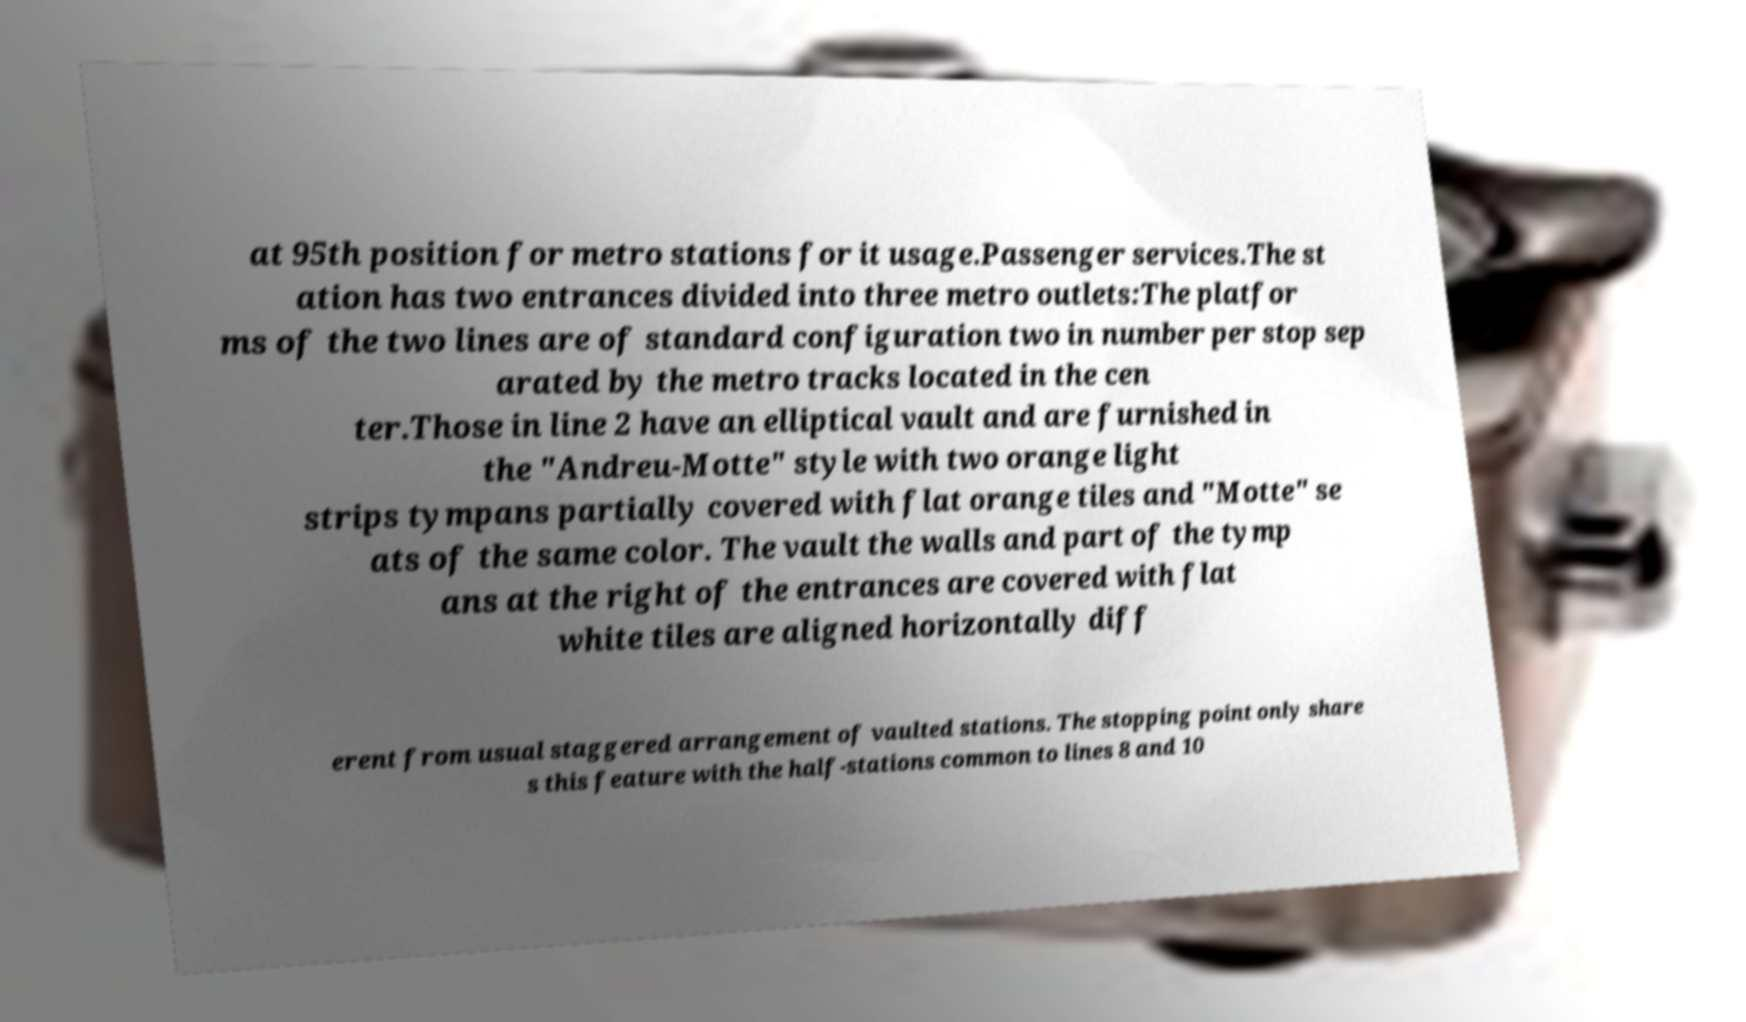Can you accurately transcribe the text from the provided image for me? at 95th position for metro stations for it usage.Passenger services.The st ation has two entrances divided into three metro outlets:The platfor ms of the two lines are of standard configuration two in number per stop sep arated by the metro tracks located in the cen ter.Those in line 2 have an elliptical vault and are furnished in the "Andreu-Motte" style with two orange light strips tympans partially covered with flat orange tiles and "Motte" se ats of the same color. The vault the walls and part of the tymp ans at the right of the entrances are covered with flat white tiles are aligned horizontally diff erent from usual staggered arrangement of vaulted stations. The stopping point only share s this feature with the half-stations common to lines 8 and 10 